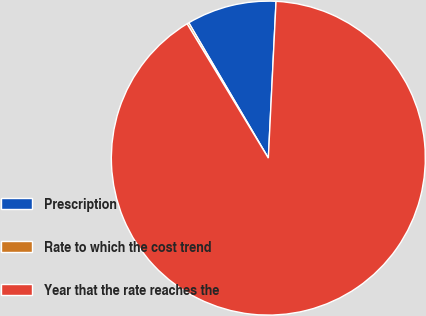Convert chart. <chart><loc_0><loc_0><loc_500><loc_500><pie_chart><fcel>Prescription<fcel>Rate to which the cost trend<fcel>Year that the rate reaches the<nl><fcel>9.24%<fcel>0.2%<fcel>90.56%<nl></chart> 